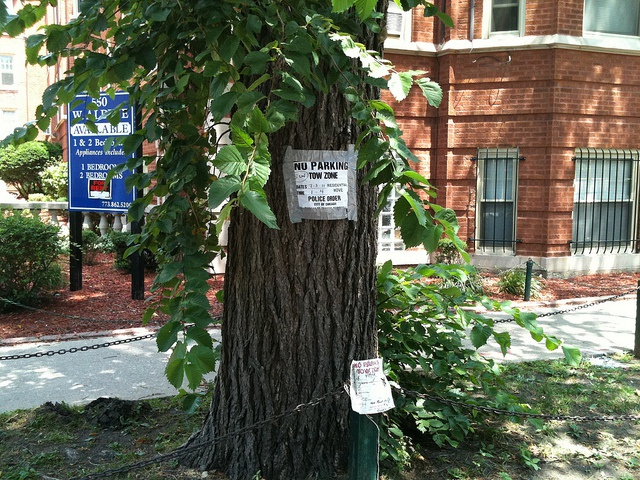Describe the objects in this image and their specific colors. I can see various objects in this image with different colors. 